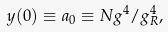Convert formula to latex. <formula><loc_0><loc_0><loc_500><loc_500>y ( 0 ) \equiv a _ { 0 } \equiv N g ^ { 4 } / g _ { R } ^ { 4 } ,</formula> 